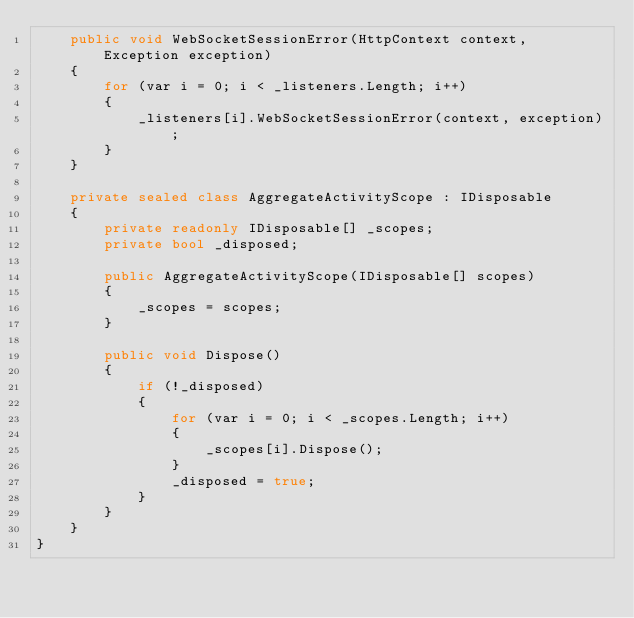<code> <loc_0><loc_0><loc_500><loc_500><_C#_>    public void WebSocketSessionError(HttpContext context, Exception exception)
    {
        for (var i = 0; i < _listeners.Length; i++)
        {
            _listeners[i].WebSocketSessionError(context, exception);
        }
    }

    private sealed class AggregateActivityScope : IDisposable
    {
        private readonly IDisposable[] _scopes;
        private bool _disposed;

        public AggregateActivityScope(IDisposable[] scopes)
        {
            _scopes = scopes;
        }

        public void Dispose()
        {
            if (!_disposed)
            {
                for (var i = 0; i < _scopes.Length; i++)
                {
                    _scopes[i].Dispose();
                }
                _disposed = true;
            }
        }
    }
}
</code> 